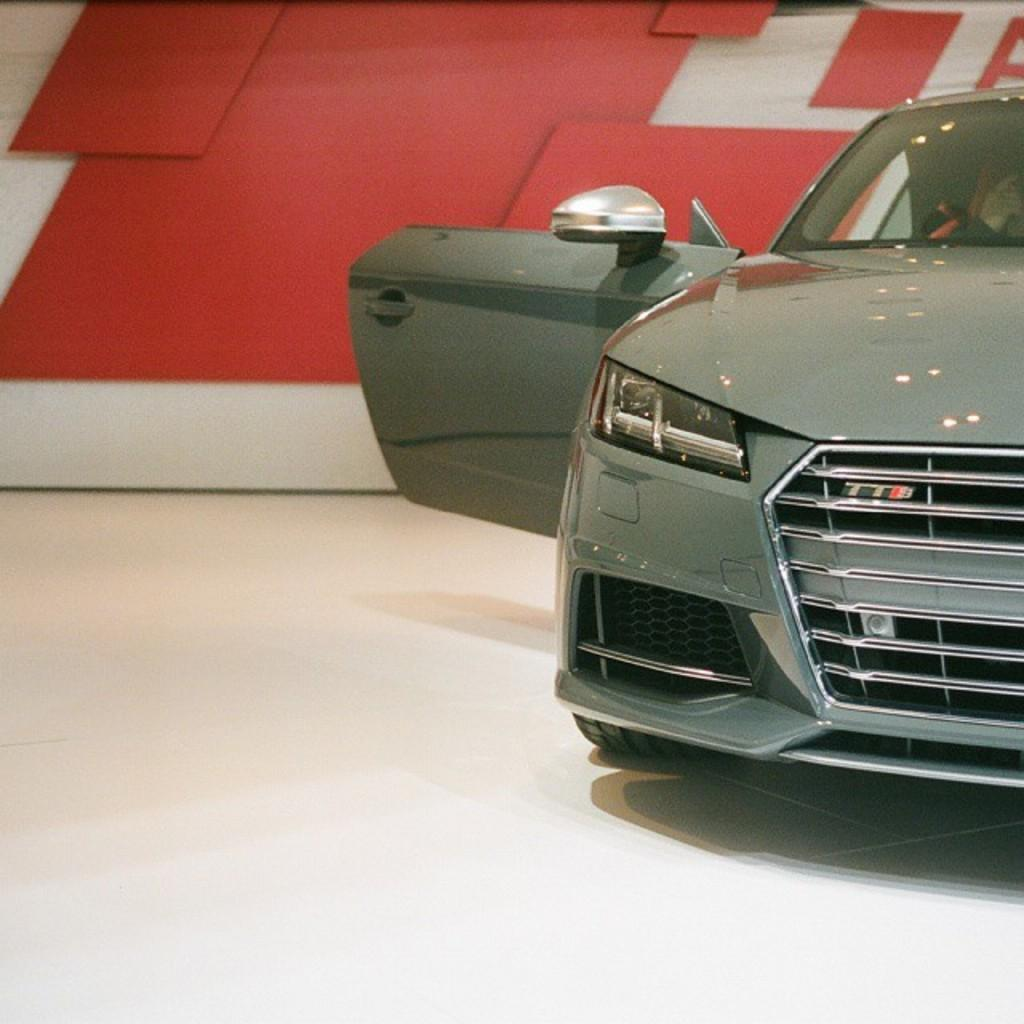What is the main subject of the image? The main subject of the image is a vehicle. What is the condition of the vehicle's door? The vehicle's door is open. What can be seen in the background of the image? There is a red and white wall in the background. What is the heart rate of the person driving the vehicle in the image? There is no information about a person driving the vehicle or their heart rate in the image. 